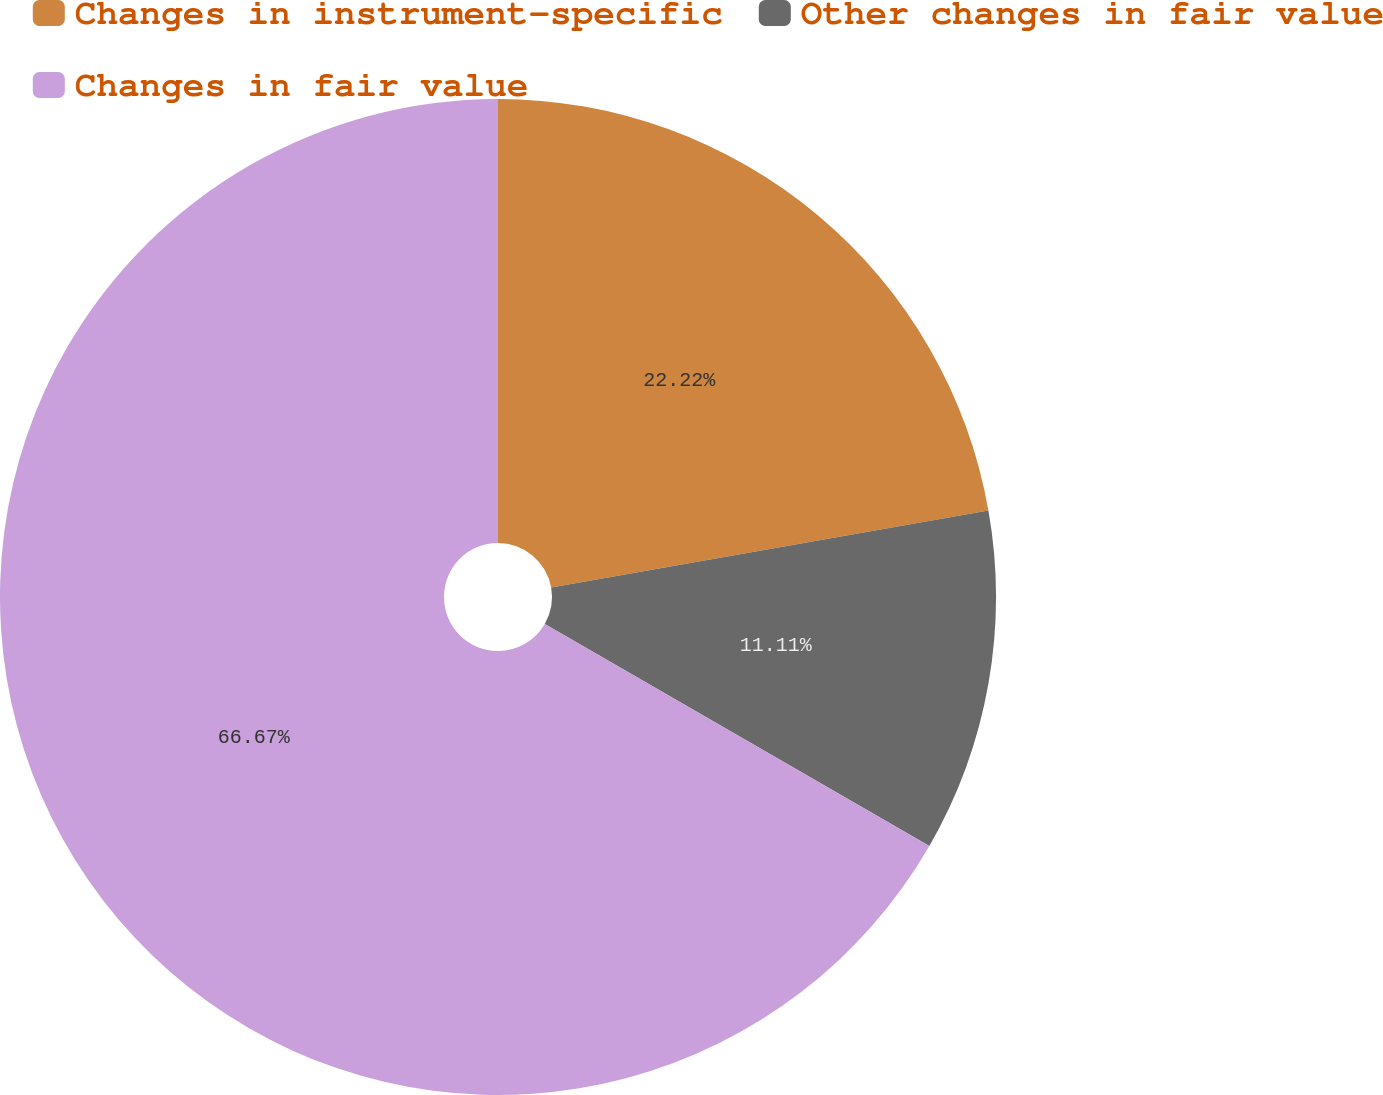Convert chart to OTSL. <chart><loc_0><loc_0><loc_500><loc_500><pie_chart><fcel>Changes in instrument-specific<fcel>Other changes in fair value<fcel>Changes in fair value<nl><fcel>22.22%<fcel>11.11%<fcel>66.67%<nl></chart> 